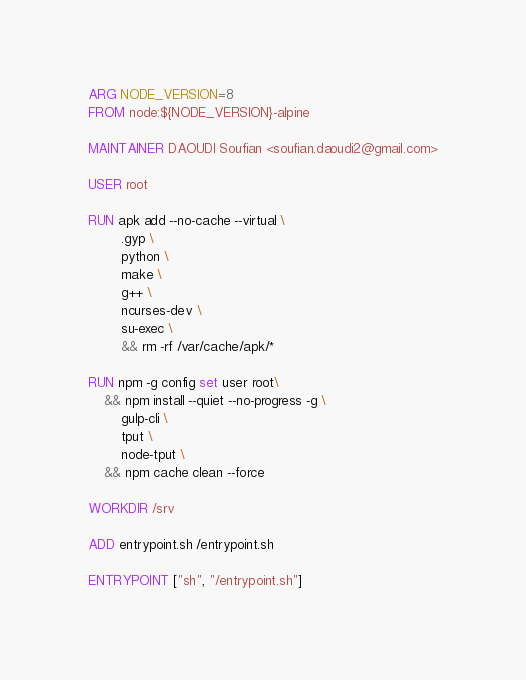Convert code to text. <code><loc_0><loc_0><loc_500><loc_500><_Dockerfile_>ARG NODE_VERSION=8
FROM node:${NODE_VERSION}-alpine

MAINTAINER DAOUDI Soufian <soufian.daoudi2@gmail.com>

USER root

RUN apk add --no-cache --virtual \
        .gyp \
        python \
        make \
        g++ \
        ncurses-dev \
        su-exec \
        && rm -rf /var/cache/apk/*

RUN npm -g config set user root\
    && npm install --quiet --no-progress -g \
    	gulp-cli \
        tput \
        node-tput \
    && npm cache clean --force

WORKDIR /srv

ADD entrypoint.sh /entrypoint.sh

ENTRYPOINT ["sh", "/entrypoint.sh"]
</code> 